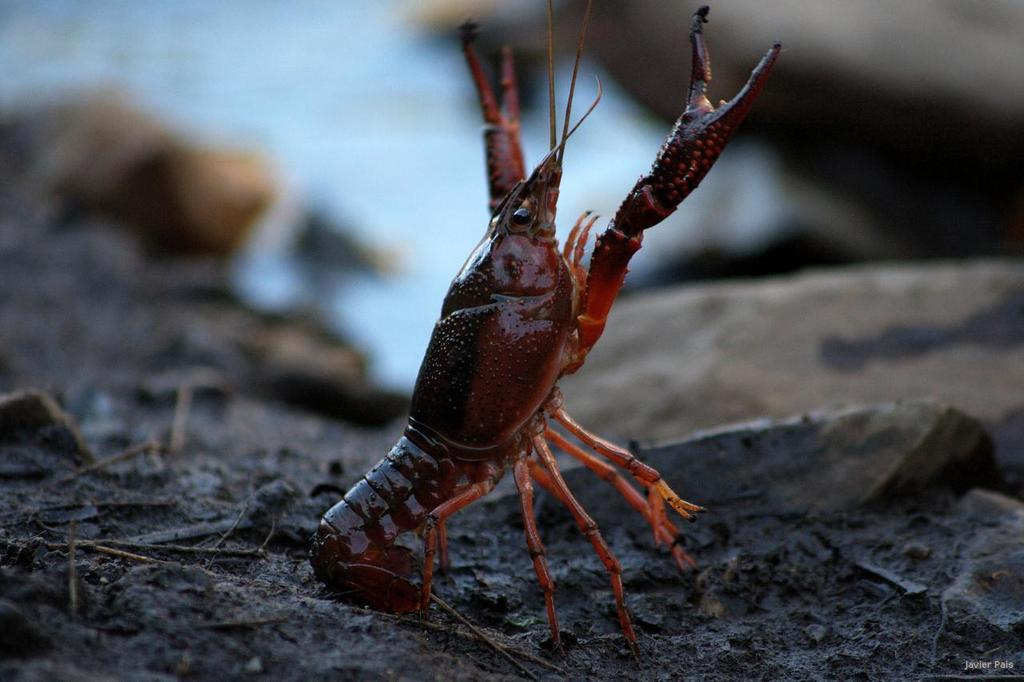What type of animal is in the image? There is a scorpion in the image. What is the scorpion standing on? The scorpion is standing on the ground. What else can be seen in the image besides the scorpion? There are stones in the image. What type of humor can be seen in the image? There is no humor present in the image; it features a scorpion standing on the ground and stones. Can you describe the ornament on the scorpion's back? There is no ornament on the scorpion's back; the image only shows a scorpion standing on the ground and stones. 